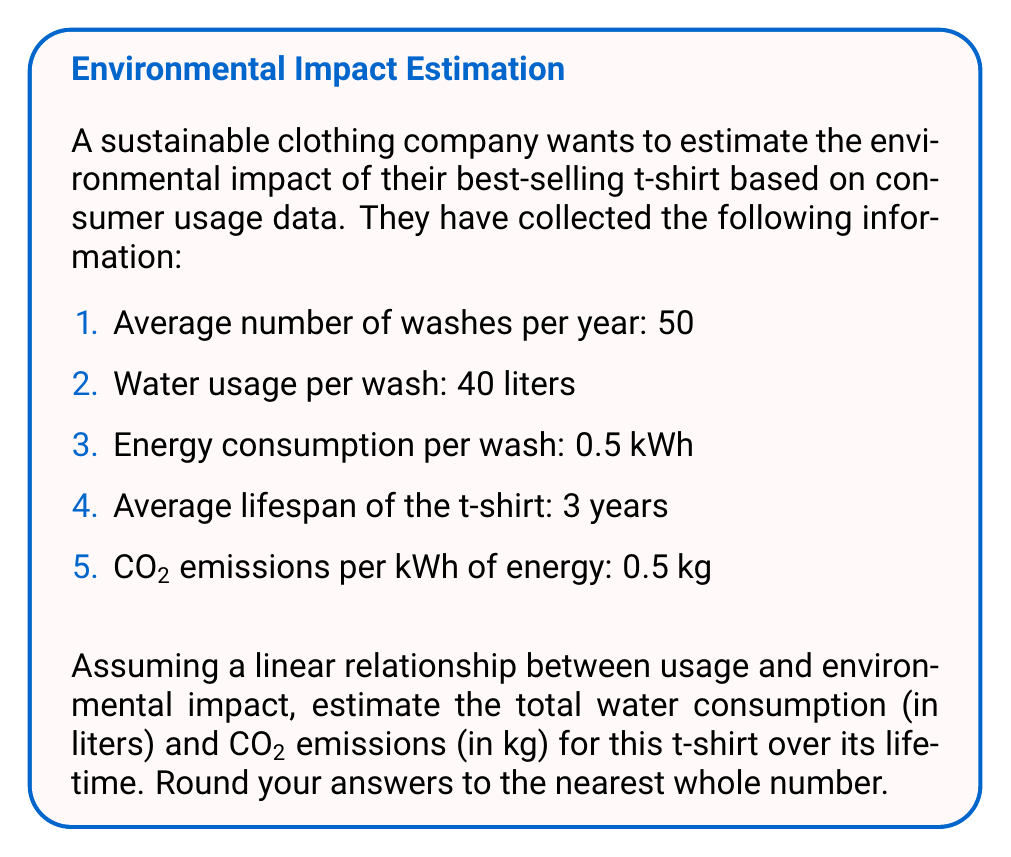Can you solve this math problem? Let's approach this problem step-by-step:

1. Calculate total number of washes over the t-shirt's lifetime:
   $$\text{Total washes} = \text{Washes per year} \times \text{Lifespan}$$
   $$\text{Total washes} = 50 \times 3 = 150 \text{ washes}$$

2. Calculate total water consumption:
   $$\text{Water consumption} = \text{Total washes} \times \text{Water per wash}$$
   $$\text{Water consumption} = 150 \times 40 = 6000 \text{ liters}$$

3. Calculate total energy consumption:
   $$\text{Energy consumption} = \text{Total washes} \times \text{Energy per wash}$$
   $$\text{Energy consumption} = 150 \times 0.5 = 75 \text{ kWh}$$

4. Calculate CO2 emissions:
   $$\text{CO2 emissions} = \text{Energy consumption} \times \text{CO2 per kWh}$$
   $$\text{CO2 emissions} = 75 \times 0.5 = 37.5 \text{ kg}$$

5. Round the results to the nearest whole number:
   Water consumption: 6000 liters (already a whole number)
   CO2 emissions: 38 kg (rounded from 37.5)
Answer: 6000 liters of water, 38 kg of CO2 